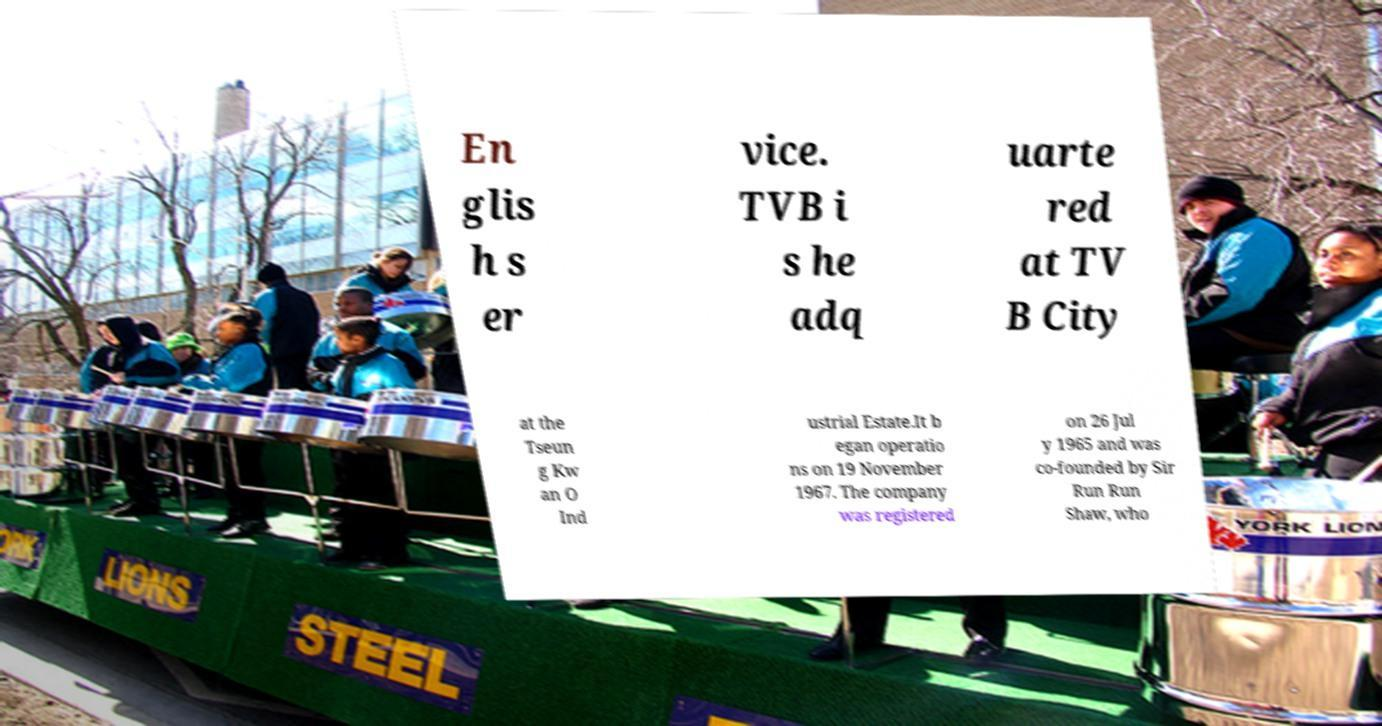Please read and relay the text visible in this image. What does it say? En glis h s er vice. TVB i s he adq uarte red at TV B City at the Tseun g Kw an O Ind ustrial Estate.It b egan operatio ns on 19 November 1967. The company was registered on 26 Jul y 1965 and was co-founded by Sir Run Run Shaw, who 